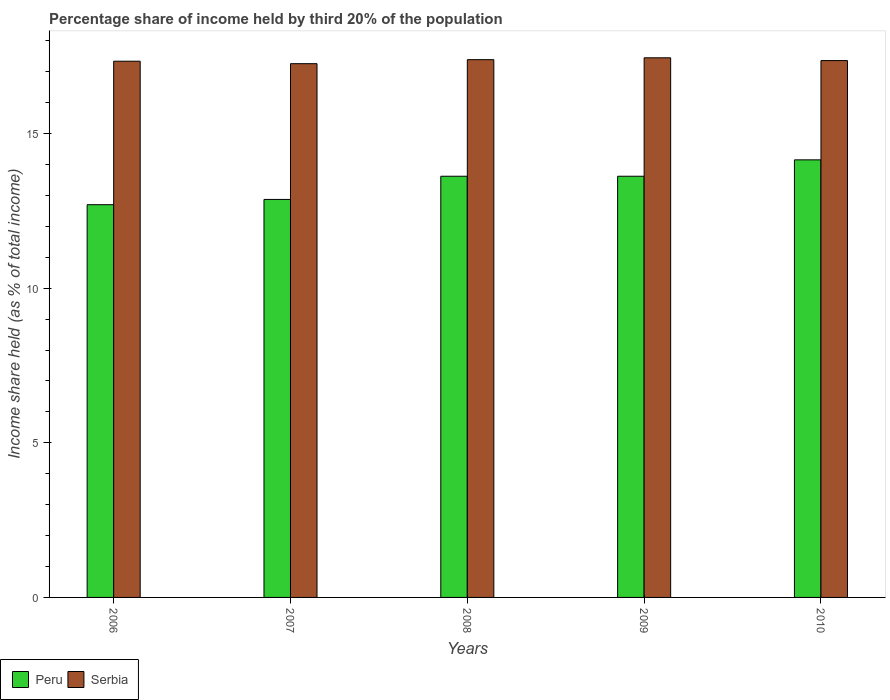How many different coloured bars are there?
Provide a short and direct response. 2. Are the number of bars per tick equal to the number of legend labels?
Provide a succinct answer. Yes. How many bars are there on the 4th tick from the right?
Provide a succinct answer. 2. What is the label of the 2nd group of bars from the left?
Ensure brevity in your answer.  2007. In how many cases, is the number of bars for a given year not equal to the number of legend labels?
Ensure brevity in your answer.  0. What is the share of income held by third 20% of the population in Peru in 2010?
Keep it short and to the point. 14.15. Across all years, what is the maximum share of income held by third 20% of the population in Peru?
Provide a succinct answer. 14.15. Across all years, what is the minimum share of income held by third 20% of the population in Serbia?
Make the answer very short. 17.26. What is the total share of income held by third 20% of the population in Serbia in the graph?
Offer a terse response. 86.8. What is the difference between the share of income held by third 20% of the population in Peru in 2006 and that in 2007?
Make the answer very short. -0.17. What is the difference between the share of income held by third 20% of the population in Peru in 2008 and the share of income held by third 20% of the population in Serbia in 2009?
Give a very brief answer. -3.83. What is the average share of income held by third 20% of the population in Peru per year?
Offer a very short reply. 13.39. In the year 2006, what is the difference between the share of income held by third 20% of the population in Peru and share of income held by third 20% of the population in Serbia?
Make the answer very short. -4.64. In how many years, is the share of income held by third 20% of the population in Serbia greater than 2 %?
Provide a short and direct response. 5. What is the ratio of the share of income held by third 20% of the population in Peru in 2006 to that in 2010?
Provide a short and direct response. 0.9. Is the difference between the share of income held by third 20% of the population in Peru in 2007 and 2009 greater than the difference between the share of income held by third 20% of the population in Serbia in 2007 and 2009?
Offer a terse response. No. What is the difference between the highest and the second highest share of income held by third 20% of the population in Serbia?
Give a very brief answer. 0.06. What is the difference between the highest and the lowest share of income held by third 20% of the population in Serbia?
Keep it short and to the point. 0.19. In how many years, is the share of income held by third 20% of the population in Serbia greater than the average share of income held by third 20% of the population in Serbia taken over all years?
Ensure brevity in your answer.  2. Are all the bars in the graph horizontal?
Offer a very short reply. No. Does the graph contain grids?
Ensure brevity in your answer.  No. Where does the legend appear in the graph?
Your answer should be compact. Bottom left. What is the title of the graph?
Your response must be concise. Percentage share of income held by third 20% of the population. Does "Lesotho" appear as one of the legend labels in the graph?
Offer a very short reply. No. What is the label or title of the X-axis?
Provide a succinct answer. Years. What is the label or title of the Y-axis?
Your answer should be compact. Income share held (as % of total income). What is the Income share held (as % of total income) in Serbia in 2006?
Offer a very short reply. 17.34. What is the Income share held (as % of total income) in Peru in 2007?
Make the answer very short. 12.87. What is the Income share held (as % of total income) in Serbia in 2007?
Your response must be concise. 17.26. What is the Income share held (as % of total income) of Peru in 2008?
Your answer should be compact. 13.62. What is the Income share held (as % of total income) of Serbia in 2008?
Your answer should be compact. 17.39. What is the Income share held (as % of total income) of Peru in 2009?
Ensure brevity in your answer.  13.62. What is the Income share held (as % of total income) of Serbia in 2009?
Provide a short and direct response. 17.45. What is the Income share held (as % of total income) of Peru in 2010?
Provide a short and direct response. 14.15. What is the Income share held (as % of total income) of Serbia in 2010?
Ensure brevity in your answer.  17.36. Across all years, what is the maximum Income share held (as % of total income) of Peru?
Keep it short and to the point. 14.15. Across all years, what is the maximum Income share held (as % of total income) of Serbia?
Provide a short and direct response. 17.45. Across all years, what is the minimum Income share held (as % of total income) of Serbia?
Provide a succinct answer. 17.26. What is the total Income share held (as % of total income) of Peru in the graph?
Your response must be concise. 66.96. What is the total Income share held (as % of total income) of Serbia in the graph?
Make the answer very short. 86.8. What is the difference between the Income share held (as % of total income) in Peru in 2006 and that in 2007?
Your answer should be compact. -0.17. What is the difference between the Income share held (as % of total income) of Peru in 2006 and that in 2008?
Keep it short and to the point. -0.92. What is the difference between the Income share held (as % of total income) in Peru in 2006 and that in 2009?
Your response must be concise. -0.92. What is the difference between the Income share held (as % of total income) of Serbia in 2006 and that in 2009?
Provide a short and direct response. -0.11. What is the difference between the Income share held (as % of total income) in Peru in 2006 and that in 2010?
Make the answer very short. -1.45. What is the difference between the Income share held (as % of total income) of Serbia in 2006 and that in 2010?
Provide a succinct answer. -0.02. What is the difference between the Income share held (as % of total income) in Peru in 2007 and that in 2008?
Make the answer very short. -0.75. What is the difference between the Income share held (as % of total income) of Serbia in 2007 and that in 2008?
Ensure brevity in your answer.  -0.13. What is the difference between the Income share held (as % of total income) of Peru in 2007 and that in 2009?
Provide a succinct answer. -0.75. What is the difference between the Income share held (as % of total income) in Serbia in 2007 and that in 2009?
Keep it short and to the point. -0.19. What is the difference between the Income share held (as % of total income) of Peru in 2007 and that in 2010?
Keep it short and to the point. -1.28. What is the difference between the Income share held (as % of total income) of Serbia in 2008 and that in 2009?
Your answer should be compact. -0.06. What is the difference between the Income share held (as % of total income) of Peru in 2008 and that in 2010?
Provide a succinct answer. -0.53. What is the difference between the Income share held (as % of total income) in Serbia in 2008 and that in 2010?
Your response must be concise. 0.03. What is the difference between the Income share held (as % of total income) in Peru in 2009 and that in 2010?
Provide a short and direct response. -0.53. What is the difference between the Income share held (as % of total income) of Serbia in 2009 and that in 2010?
Provide a succinct answer. 0.09. What is the difference between the Income share held (as % of total income) of Peru in 2006 and the Income share held (as % of total income) of Serbia in 2007?
Your answer should be very brief. -4.56. What is the difference between the Income share held (as % of total income) of Peru in 2006 and the Income share held (as % of total income) of Serbia in 2008?
Provide a short and direct response. -4.69. What is the difference between the Income share held (as % of total income) of Peru in 2006 and the Income share held (as % of total income) of Serbia in 2009?
Your response must be concise. -4.75. What is the difference between the Income share held (as % of total income) in Peru in 2006 and the Income share held (as % of total income) in Serbia in 2010?
Ensure brevity in your answer.  -4.66. What is the difference between the Income share held (as % of total income) of Peru in 2007 and the Income share held (as % of total income) of Serbia in 2008?
Make the answer very short. -4.52. What is the difference between the Income share held (as % of total income) of Peru in 2007 and the Income share held (as % of total income) of Serbia in 2009?
Provide a short and direct response. -4.58. What is the difference between the Income share held (as % of total income) in Peru in 2007 and the Income share held (as % of total income) in Serbia in 2010?
Keep it short and to the point. -4.49. What is the difference between the Income share held (as % of total income) in Peru in 2008 and the Income share held (as % of total income) in Serbia in 2009?
Your response must be concise. -3.83. What is the difference between the Income share held (as % of total income) of Peru in 2008 and the Income share held (as % of total income) of Serbia in 2010?
Provide a short and direct response. -3.74. What is the difference between the Income share held (as % of total income) of Peru in 2009 and the Income share held (as % of total income) of Serbia in 2010?
Your answer should be very brief. -3.74. What is the average Income share held (as % of total income) of Peru per year?
Make the answer very short. 13.39. What is the average Income share held (as % of total income) in Serbia per year?
Your answer should be compact. 17.36. In the year 2006, what is the difference between the Income share held (as % of total income) of Peru and Income share held (as % of total income) of Serbia?
Your answer should be very brief. -4.64. In the year 2007, what is the difference between the Income share held (as % of total income) in Peru and Income share held (as % of total income) in Serbia?
Offer a very short reply. -4.39. In the year 2008, what is the difference between the Income share held (as % of total income) in Peru and Income share held (as % of total income) in Serbia?
Give a very brief answer. -3.77. In the year 2009, what is the difference between the Income share held (as % of total income) in Peru and Income share held (as % of total income) in Serbia?
Offer a terse response. -3.83. In the year 2010, what is the difference between the Income share held (as % of total income) of Peru and Income share held (as % of total income) of Serbia?
Your answer should be very brief. -3.21. What is the ratio of the Income share held (as % of total income) of Peru in 2006 to that in 2007?
Ensure brevity in your answer.  0.99. What is the ratio of the Income share held (as % of total income) in Peru in 2006 to that in 2008?
Your answer should be very brief. 0.93. What is the ratio of the Income share held (as % of total income) in Peru in 2006 to that in 2009?
Ensure brevity in your answer.  0.93. What is the ratio of the Income share held (as % of total income) of Peru in 2006 to that in 2010?
Your response must be concise. 0.9. What is the ratio of the Income share held (as % of total income) of Peru in 2007 to that in 2008?
Your answer should be very brief. 0.94. What is the ratio of the Income share held (as % of total income) of Peru in 2007 to that in 2009?
Your answer should be very brief. 0.94. What is the ratio of the Income share held (as % of total income) of Peru in 2007 to that in 2010?
Keep it short and to the point. 0.91. What is the ratio of the Income share held (as % of total income) in Peru in 2008 to that in 2009?
Provide a short and direct response. 1. What is the ratio of the Income share held (as % of total income) of Peru in 2008 to that in 2010?
Give a very brief answer. 0.96. What is the ratio of the Income share held (as % of total income) in Peru in 2009 to that in 2010?
Keep it short and to the point. 0.96. What is the difference between the highest and the second highest Income share held (as % of total income) in Peru?
Offer a terse response. 0.53. What is the difference between the highest and the second highest Income share held (as % of total income) in Serbia?
Make the answer very short. 0.06. What is the difference between the highest and the lowest Income share held (as % of total income) in Peru?
Your answer should be very brief. 1.45. What is the difference between the highest and the lowest Income share held (as % of total income) of Serbia?
Give a very brief answer. 0.19. 